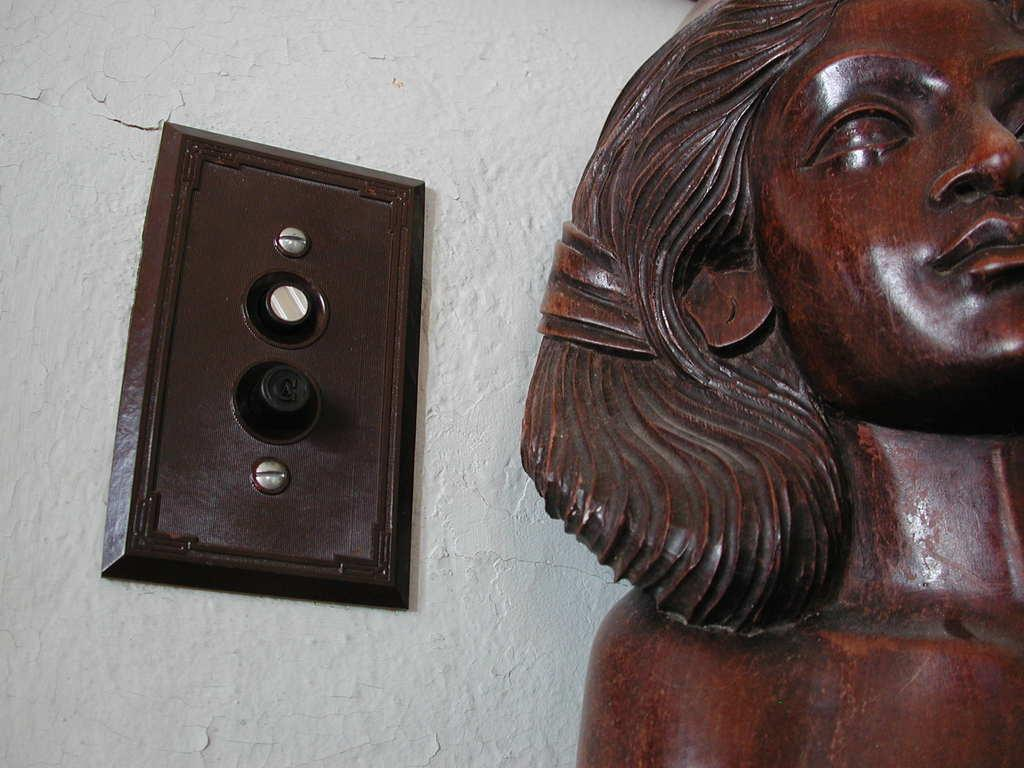What is the main subject in the foreground of the image? There is a sculpture in the foreground of the image. On which side of the image is the sculpture located? The sculpture is on the right side. What is another object visible in the image? There is a brown board on the wall in the image. Is the sculpture sinking into quicksand in the image? There is no quicksand present in the image, and therefore the sculpture is not sinking into it. Can you see a clam attached to the sculpture in the image? There is no clam present or attached to the sculpture in the image. 